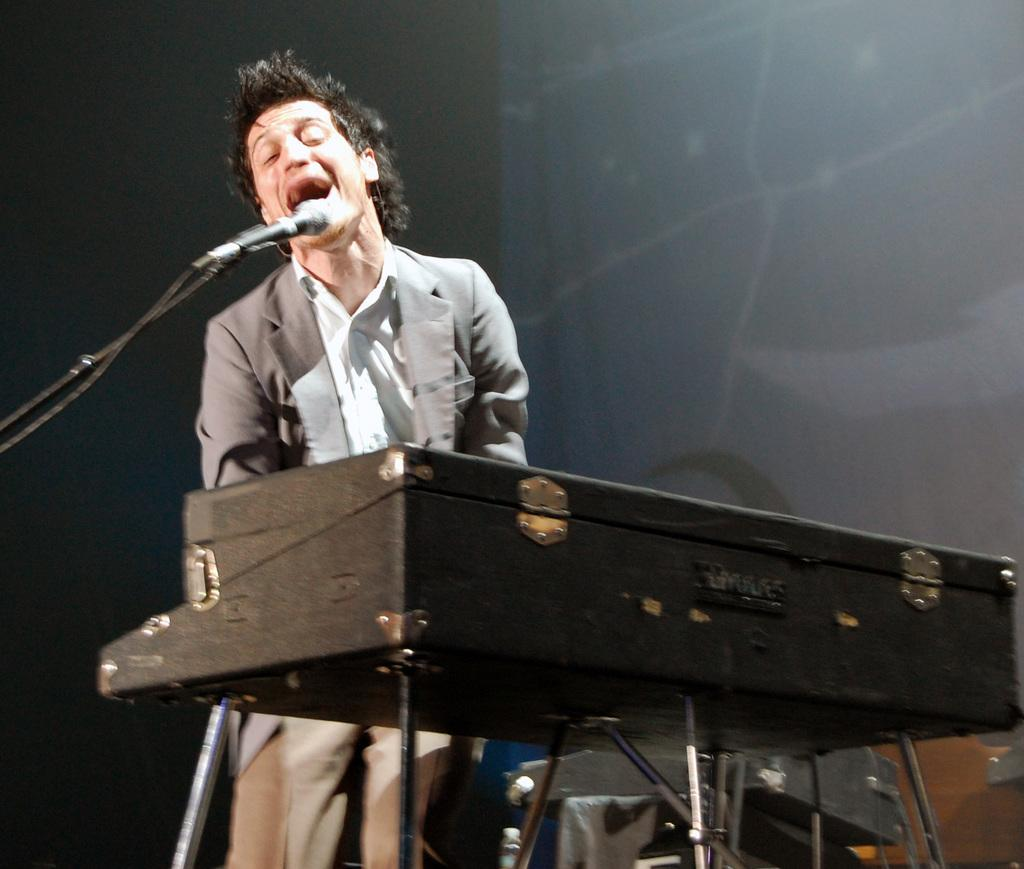What is the person in the image doing? The person is singing in the image. What can be seen on the left side of the image? There is a microphone with a stand on the left side. What musical instrument is present in the image? There is a keyboard with a stand in the image. What is visible in the background of the image? There is a wall in the background. What type of furniture is being used to control the sound in the image? There is no furniture present in the image that is used to control the sound. 